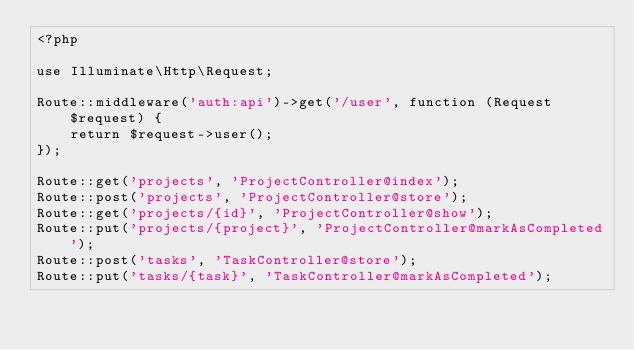Convert code to text. <code><loc_0><loc_0><loc_500><loc_500><_PHP_><?php

use Illuminate\Http\Request;

Route::middleware('auth:api')->get('/user', function (Request $request) {
    return $request->user();
});

Route::get('projects', 'ProjectController@index');
Route::post('projects', 'ProjectController@store');
Route::get('projects/{id}', 'ProjectController@show');
Route::put('projects/{project}', 'ProjectController@markAsCompleted');
Route::post('tasks', 'TaskController@store');
Route::put('tasks/{task}', 'TaskController@markAsCompleted');
</code> 